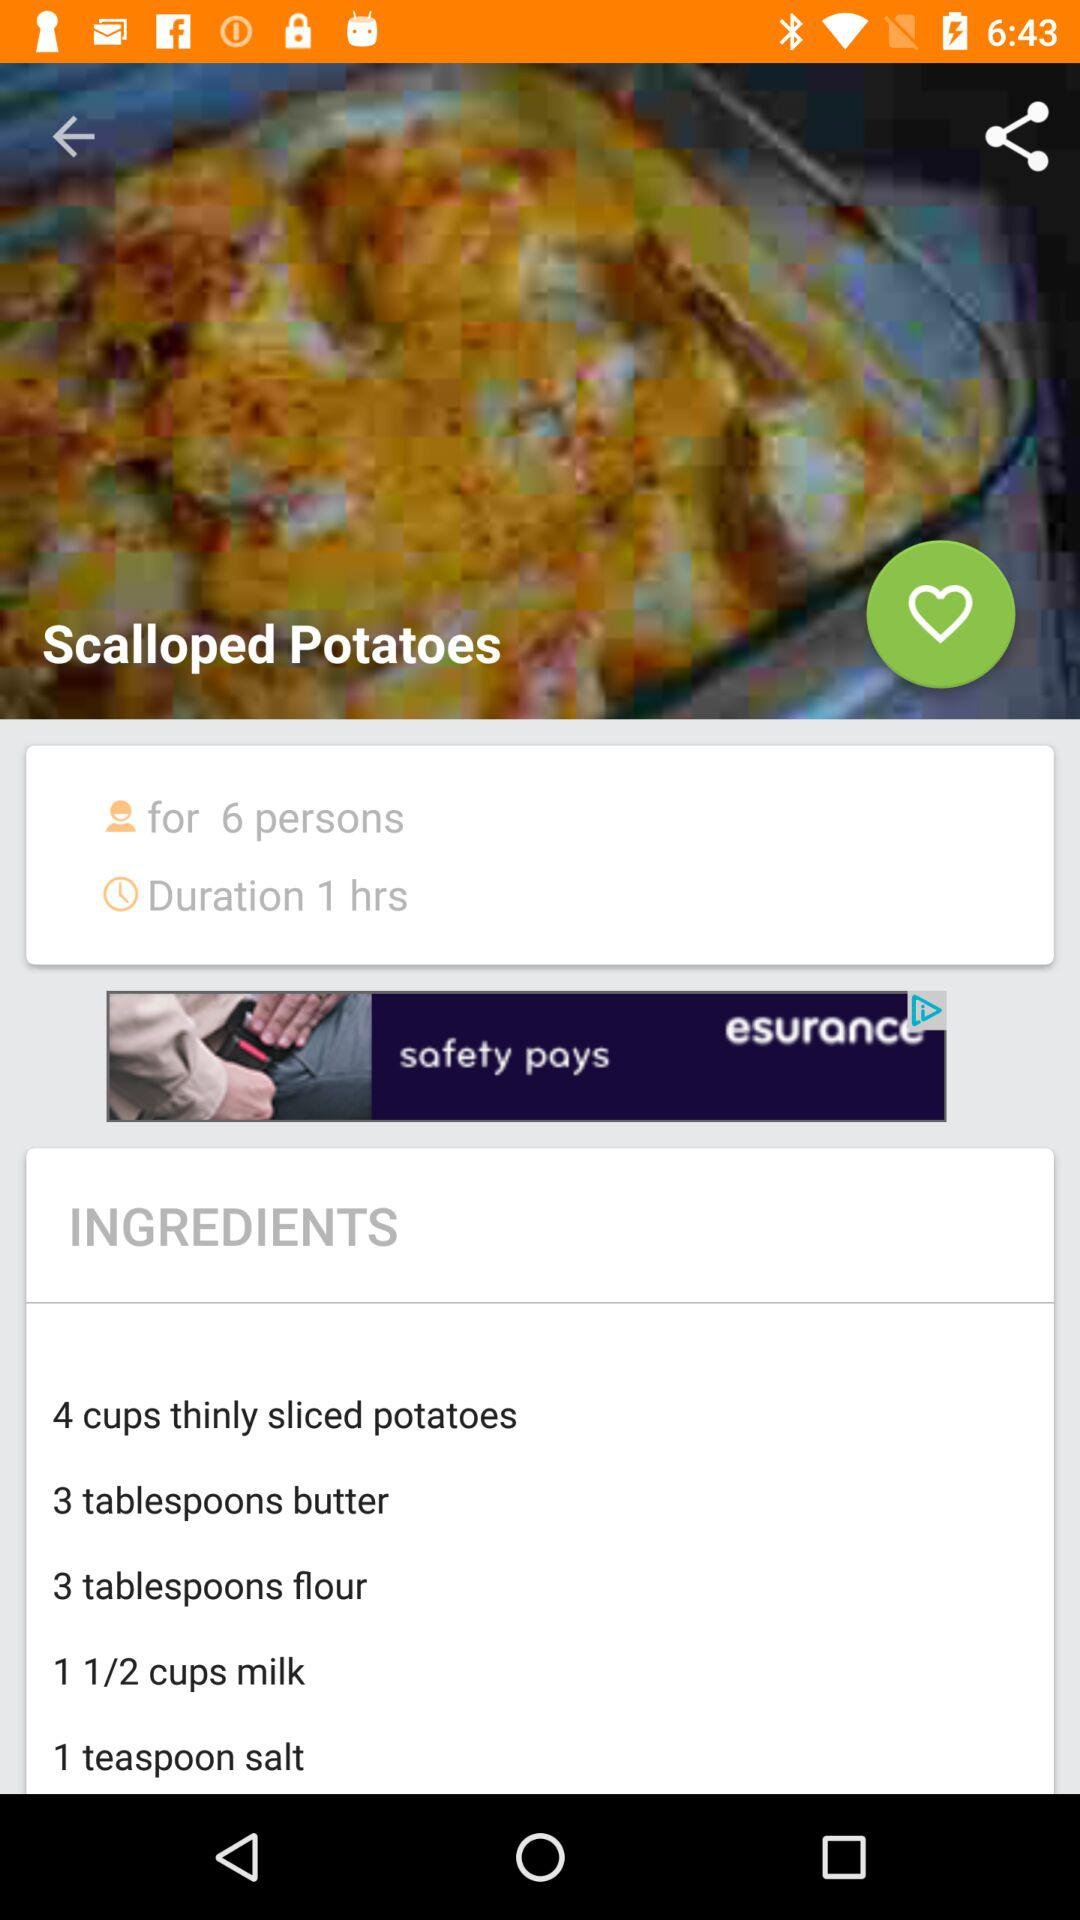What is the time required to make scalloped potatoes? The required time to make scalloped potatoes is 1 hour. 